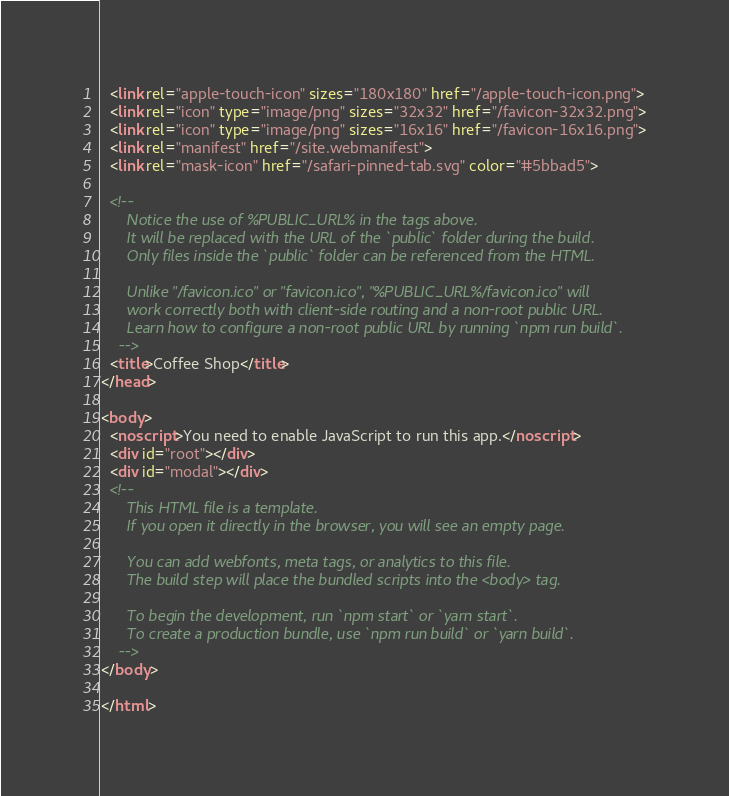<code> <loc_0><loc_0><loc_500><loc_500><_HTML_>  <link rel="apple-touch-icon" sizes="180x180" href="/apple-touch-icon.png">
  <link rel="icon" type="image/png" sizes="32x32" href="/favicon-32x32.png">
  <link rel="icon" type="image/png" sizes="16x16" href="/favicon-16x16.png">
  <link rel="manifest" href="/site.webmanifest">
  <link rel="mask-icon" href="/safari-pinned-tab.svg" color="#5bbad5">

  <!--
      Notice the use of %PUBLIC_URL% in the tags above.
      It will be replaced with the URL of the `public` folder during the build.
      Only files inside the `public` folder can be referenced from the HTML.

      Unlike "/favicon.ico" or "favicon.ico", "%PUBLIC_URL%/favicon.ico" will
      work correctly both with client-side routing and a non-root public URL.
      Learn how to configure a non-root public URL by running `npm run build`.
    -->
  <title>Coffee Shop</title>
</head>

<body>
  <noscript>You need to enable JavaScript to run this app.</noscript>
  <div id="root"></div>
  <div id="modal"></div>
  <!--
      This HTML file is a template.
      If you open it directly in the browser, you will see an empty page.

      You can add webfonts, meta tags, or analytics to this file.
      The build step will place the bundled scripts into the <body> tag.

      To begin the development, run `npm start` or `yarn start`.
      To create a production bundle, use `npm run build` or `yarn build`.
    -->
</body>

</html></code> 